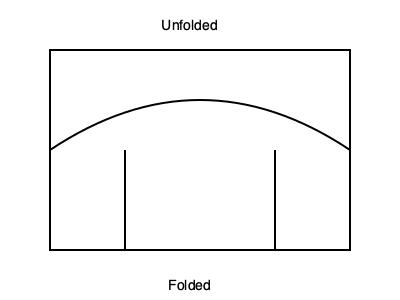A paper model of a uterus is shown above in its unfolded state. If the model is folded along the curved line, which statement best describes the resulting shape in relation to a real uterus? To answer this question, we need to mentally visualize the folding process:

1. The rectangular shape represents the unfolded paper model.
2. The curved line in the middle represents the fold line.
3. When folded, the top half will bend over the bottom half.
4. The two vertical lines on the sides will meet, forming the sides of the folded shape.

After folding:
- The curved top edge will form the fundus (top) of the uterus.
- The vertical sides will represent the lateral walls.
- The bottom edge will become the cervical opening.

This folded shape closely mimics the general anatomy of a uterus:
- Inverted triangle shape
- Rounded top (fundus)
- Narrowing towards the bottom (cervix)

In reproductive mental health, understanding this 3D structure can help clients visualize and comprehend uterine anatomy, which may be beneficial in discussing fertility issues or treatments.
Answer: The folded model accurately represents the general shape and proportions of a uterus. 